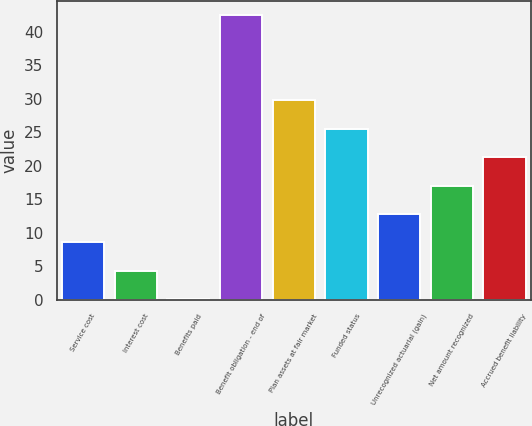Convert chart to OTSL. <chart><loc_0><loc_0><loc_500><loc_500><bar_chart><fcel>Service cost<fcel>Interest cost<fcel>Benefits paid<fcel>Benefit obligation - end of<fcel>Plan assets at fair market<fcel>Funded status<fcel>Unrecognized actuarial (gain)<fcel>Net amount recognized<fcel>Accrued benefit liability<nl><fcel>8.58<fcel>4.34<fcel>0.1<fcel>42.5<fcel>29.78<fcel>25.54<fcel>12.82<fcel>17.06<fcel>21.3<nl></chart> 